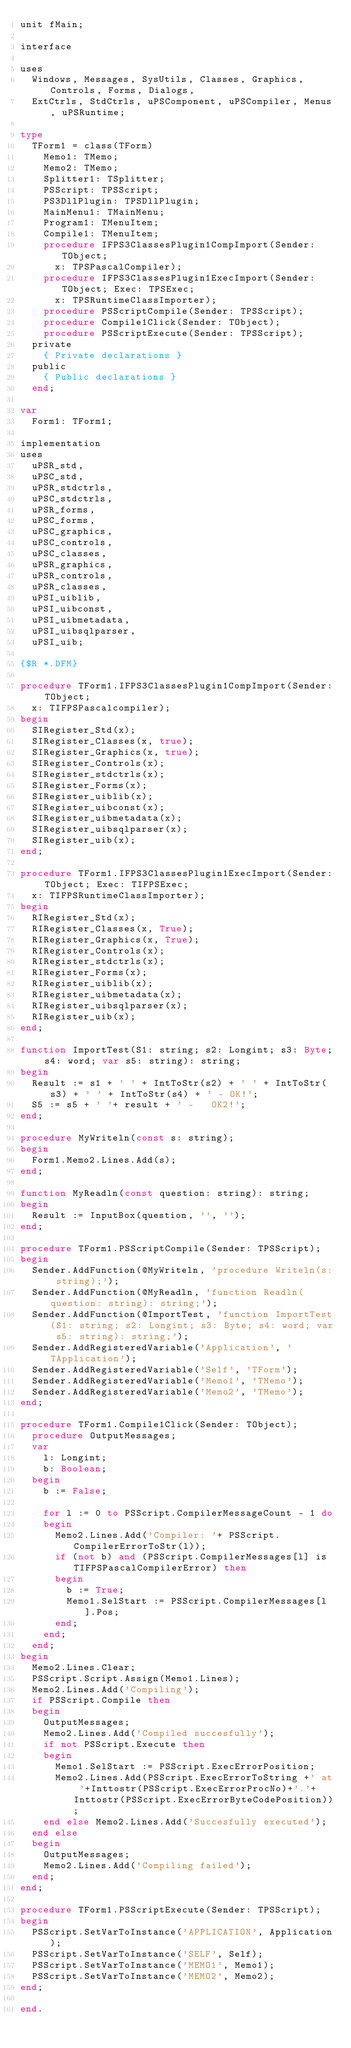Convert code to text. <code><loc_0><loc_0><loc_500><loc_500><_Pascal_>unit fMain;

interface

uses
  Windows, Messages, SysUtils, Classes, Graphics, Controls, Forms, Dialogs,
  ExtCtrls, StdCtrls, uPSComponent, uPSCompiler, Menus, uPSRuntime;

type
  TForm1 = class(TForm)
    Memo1: TMemo;
    Memo2: TMemo;
    Splitter1: TSplitter;
    PSScript: TPSScript;
    PS3DllPlugin: TPSDllPlugin;
    MainMenu1: TMainMenu;
    Program1: TMenuItem;
    Compile1: TMenuItem;
    procedure IFPS3ClassesPlugin1CompImport(Sender: TObject;
      x: TPSPascalCompiler);
    procedure IFPS3ClassesPlugin1ExecImport(Sender: TObject; Exec: TPSExec;
      x: TPSRuntimeClassImporter);
    procedure PSScriptCompile(Sender: TPSScript);
    procedure Compile1Click(Sender: TObject);
    procedure PSScriptExecute(Sender: TPSScript);
  private
    { Private declarations }
  public
    { Public declarations }
  end;

var
  Form1: TForm1;

implementation
uses
  uPSR_std,
  uPSC_std,
  uPSR_stdctrls,
  uPSC_stdctrls,
  uPSR_forms,
  uPSC_forms,
  uPSC_graphics,
  uPSC_controls,
  uPSC_classes,
  uPSR_graphics,
  uPSR_controls,
  uPSR_classes,
  uPSI_uiblib,
  uPSI_uibconst,
  uPSI_uibmetadata,
  uPSI_uibsqlparser,
  uPSI_uib;

{$R *.DFM}

procedure TForm1.IFPS3ClassesPlugin1CompImport(Sender: TObject;
  x: TIFPSPascalcompiler);
begin
  SIRegister_Std(x);
  SIRegister_Classes(x, true);
  SIRegister_Graphics(x, true);
  SIRegister_Controls(x);
  SIRegister_stdctrls(x);
  SIRegister_Forms(x);
  SIRegister_uiblib(x);
  SIRegister_uibconst(x);
  SIRegister_uibmetadata(x);
  SIRegister_uibsqlparser(x);
  SIRegister_uib(x);
end;

procedure TForm1.IFPS3ClassesPlugin1ExecImport(Sender: TObject; Exec: TIFPSExec;
  x: TIFPSRuntimeClassImporter);
begin
  RIRegister_Std(x);
  RIRegister_Classes(x, True);
  RIRegister_Graphics(x, True);
  RIRegister_Controls(x);
  RIRegister_stdctrls(x);
  RIRegister_Forms(x);
  RIRegister_uiblib(x);
  RIRegister_uibmetadata(x);
  RIRegister_uibsqlparser(x);
  RIRegister_uib(x);
end;

function ImportTest(S1: string; s2: Longint; s3: Byte; s4: word; var s5: string): string;
begin
  Result := s1 + ' ' + IntToStr(s2) + ' ' + IntToStr(s3) + ' ' + IntToStr(s4) + ' - OK!';
  S5 := s5 + ' '+ result + ' -   OK2!';
end;

procedure MyWriteln(const s: string);
begin
  Form1.Memo2.Lines.Add(s);
end;

function MyReadln(const question: string): string;
begin
  Result := InputBox(question, '', '');
end;

procedure TForm1.PSScriptCompile(Sender: TPSScript);
begin
  Sender.AddFunction(@MyWriteln, 'procedure Writeln(s: string);');
  Sender.AddFunction(@MyReadln, 'function Readln(question: string): string;');
  Sender.AddFunction(@ImportTest, 'function ImportTest(S1: string; s2: Longint; s3: Byte; s4: word; var s5: string): string;');
  Sender.AddRegisteredVariable('Application', 'TApplication');
  Sender.AddRegisteredVariable('Self', 'TForm');
  Sender.AddRegisteredVariable('Memo1', 'TMemo');
  Sender.AddRegisteredVariable('Memo2', 'TMemo');
end;

procedure TForm1.Compile1Click(Sender: TObject);
  procedure OutputMessages;
  var
    l: Longint;
    b: Boolean;
  begin
    b := False;

    for l := 0 to PSScript.CompilerMessageCount - 1 do
    begin
      Memo2.Lines.Add('Compiler: '+ PSScript.CompilerErrorToStr(l));
      if (not b) and (PSScript.CompilerMessages[l] is TIFPSPascalCompilerError) then
      begin
        b := True;
        Memo1.SelStart := PSScript.CompilerMessages[l].Pos;
      end;
    end;
  end;
begin
  Memo2.Lines.Clear;
  PSScript.Script.Assign(Memo1.Lines);
  Memo2.Lines.Add('Compiling');
  if PSScript.Compile then
  begin
    OutputMessages;
    Memo2.Lines.Add('Compiled succesfully');
    if not PSScript.Execute then
    begin
      Memo1.SelStart := PSScript.ExecErrorPosition;
      Memo2.Lines.Add(PSScript.ExecErrorToString +' at '+Inttostr(PSScript.ExecErrorProcNo)+'.'+Inttostr(PSScript.ExecErrorByteCodePosition));
    end else Memo2.Lines.Add('Succesfully executed');
  end else
  begin
    OutputMessages;
    Memo2.Lines.Add('Compiling failed');
  end;
end;

procedure TForm1.PSScriptExecute(Sender: TPSScript);
begin
  PSScript.SetVarToInstance('APPLICATION', Application);
  PSScript.SetVarToInstance('SELF', Self);
  PSScript.SetVarToInstance('MEMO1', Memo1);
  PSScript.SetVarToInstance('MEMO2', Memo2);
end;

end.
</code> 